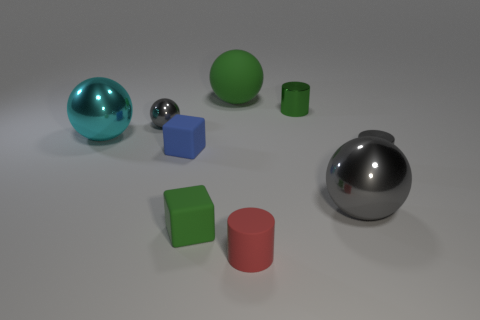What number of green spheres are there?
Provide a succinct answer. 1. There is a tiny green object that is behind the tiny gray metallic object left of the gray metallic ball that is to the right of the small red object; what is it made of?
Keep it short and to the point. Metal. Is there a cyan thing made of the same material as the small sphere?
Your response must be concise. Yes. Do the tiny green cylinder and the small blue block have the same material?
Ensure brevity in your answer.  No. What number of blocks are cyan metal things or green metallic objects?
Offer a very short reply. 0. The big thing that is made of the same material as the cyan ball is what color?
Offer a terse response. Gray. Are there fewer tiny matte cylinders than large cyan rubber cylinders?
Offer a terse response. No. Does the tiny gray metal thing that is behind the big cyan object have the same shape as the rubber thing that is behind the green metallic cylinder?
Provide a short and direct response. Yes. How many objects are green matte objects or gray things?
Make the answer very short. 5. There is a ball that is the same size as the rubber cylinder; what color is it?
Offer a terse response. Gray. 